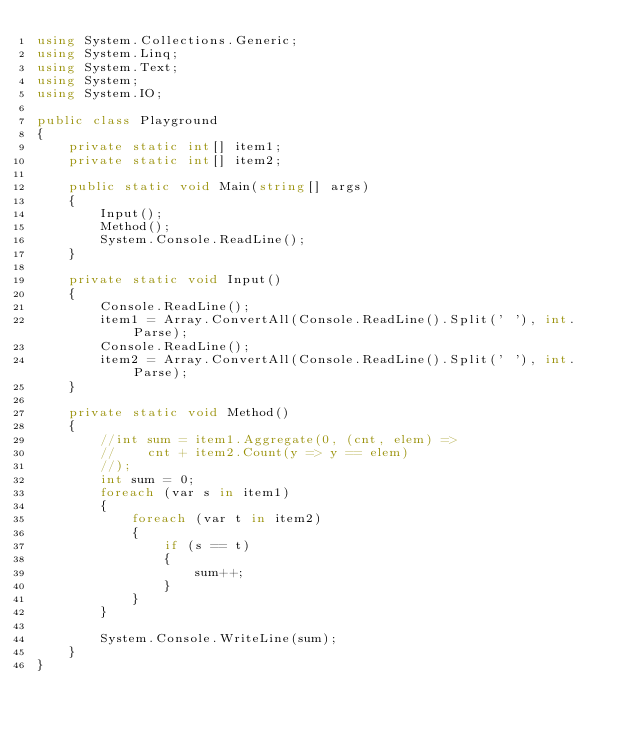<code> <loc_0><loc_0><loc_500><loc_500><_C#_>using System.Collections.Generic;
using System.Linq;
using System.Text;
using System;
using System.IO;

public class Playground
{
    private static int[] item1;
    private static int[] item2;

    public static void Main(string[] args)
    {
        Input();
        Method();
        System.Console.ReadLine();
    }

    private static void Input()
    {
        Console.ReadLine();
        item1 = Array.ConvertAll(Console.ReadLine().Split(' '), int.Parse);
        Console.ReadLine();
        item2 = Array.ConvertAll(Console.ReadLine().Split(' '), int.Parse);
    }

    private static void Method()
    {
        //int sum = item1.Aggregate(0, (cnt, elem) =>
        //    cnt + item2.Count(y => y == elem)
        //);
        int sum = 0;
        foreach (var s in item1)
        {
            foreach (var t in item2)
            {
                if (s == t)
                {
                    sum++;
                }
            }
        }

        System.Console.WriteLine(sum);
    }
}</code> 